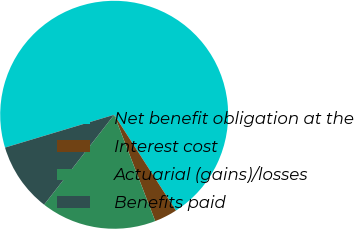Convert chart to OTSL. <chart><loc_0><loc_0><loc_500><loc_500><pie_chart><fcel>Net benefit obligation at the<fcel>Interest cost<fcel>Actuarial (gains)/losses<fcel>Benefits paid<nl><fcel>70.53%<fcel>3.25%<fcel>16.4%<fcel>9.82%<nl></chart> 